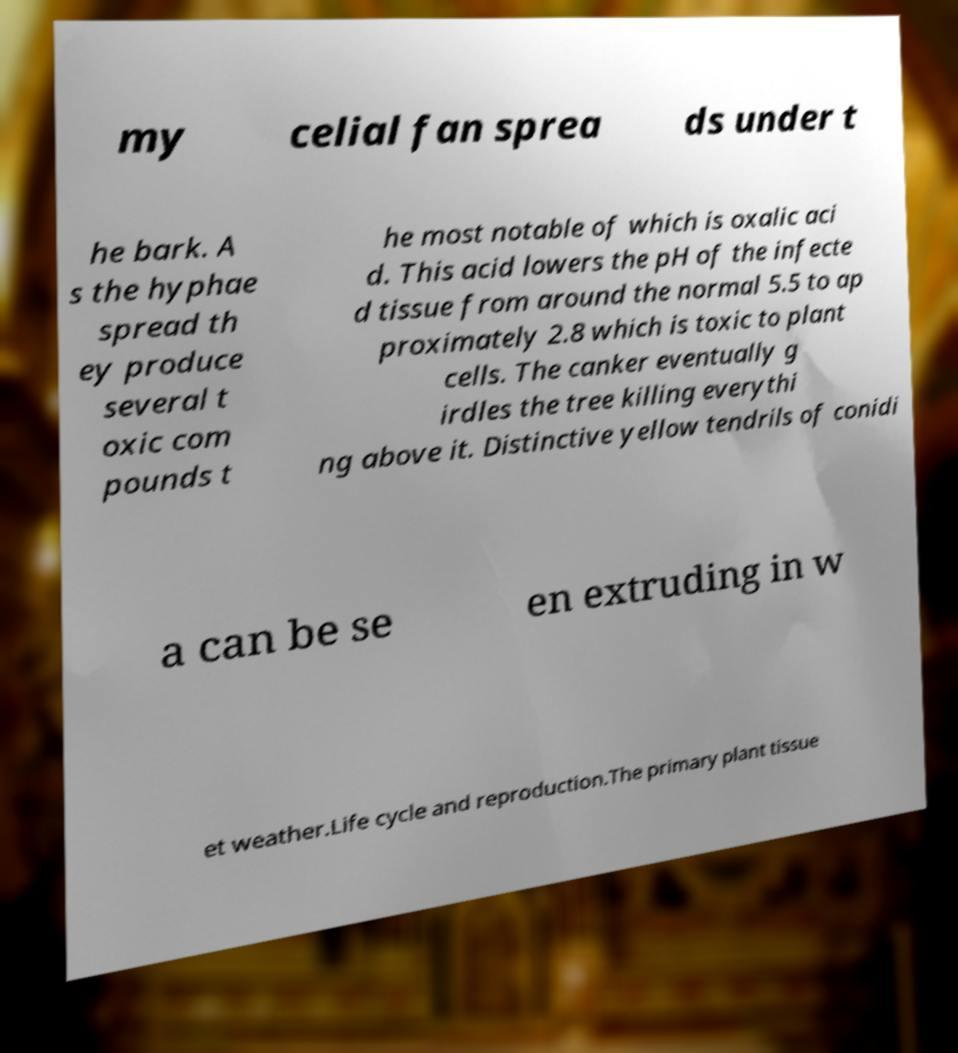Please identify and transcribe the text found in this image. my celial fan sprea ds under t he bark. A s the hyphae spread th ey produce several t oxic com pounds t he most notable of which is oxalic aci d. This acid lowers the pH of the infecte d tissue from around the normal 5.5 to ap proximately 2.8 which is toxic to plant cells. The canker eventually g irdles the tree killing everythi ng above it. Distinctive yellow tendrils of conidi a can be se en extruding in w et weather.Life cycle and reproduction.The primary plant tissue 